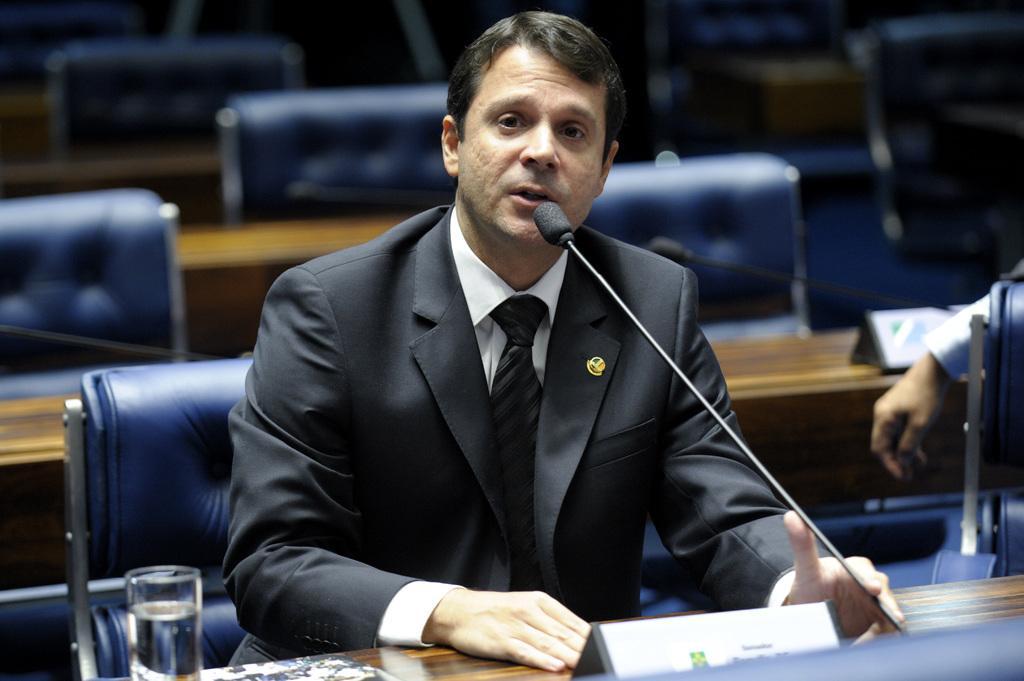Please provide a concise description of this image. This picture is clicked inside. In the center there is a man wearing suit, sitting on the chair and seems to be talking. In the foreground there is a wooden table to which a microphone is attached and we can see a glass of water and a name plate is placed on the top of the table. On the right corner there is another person. In the background we can see the tables and the blue color chairs placed on the ground. 